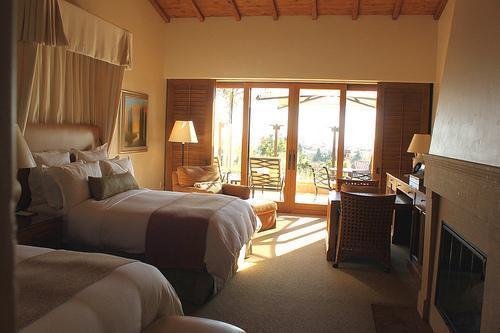How many lamps are in the room?
Give a very brief answer. 3. 